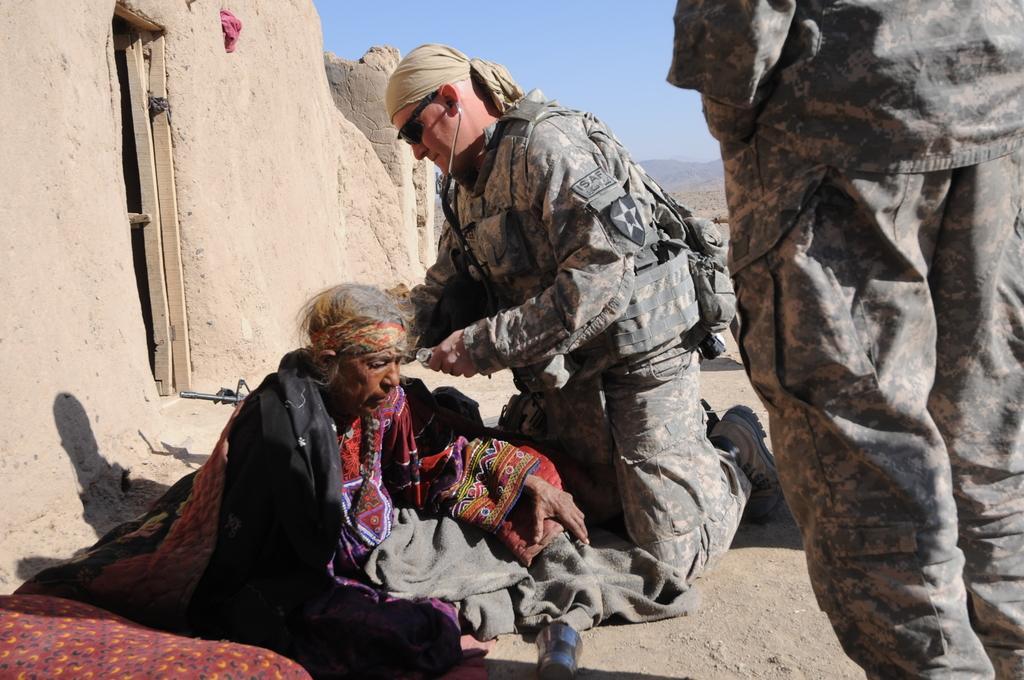Could you give a brief overview of what you see in this image? In this image we can see a two persons in the middle and among them a person is holding an object. On the right side, we can see a person truncated. On the left side, we can see a wall of a house. At the top we can see the sky. 